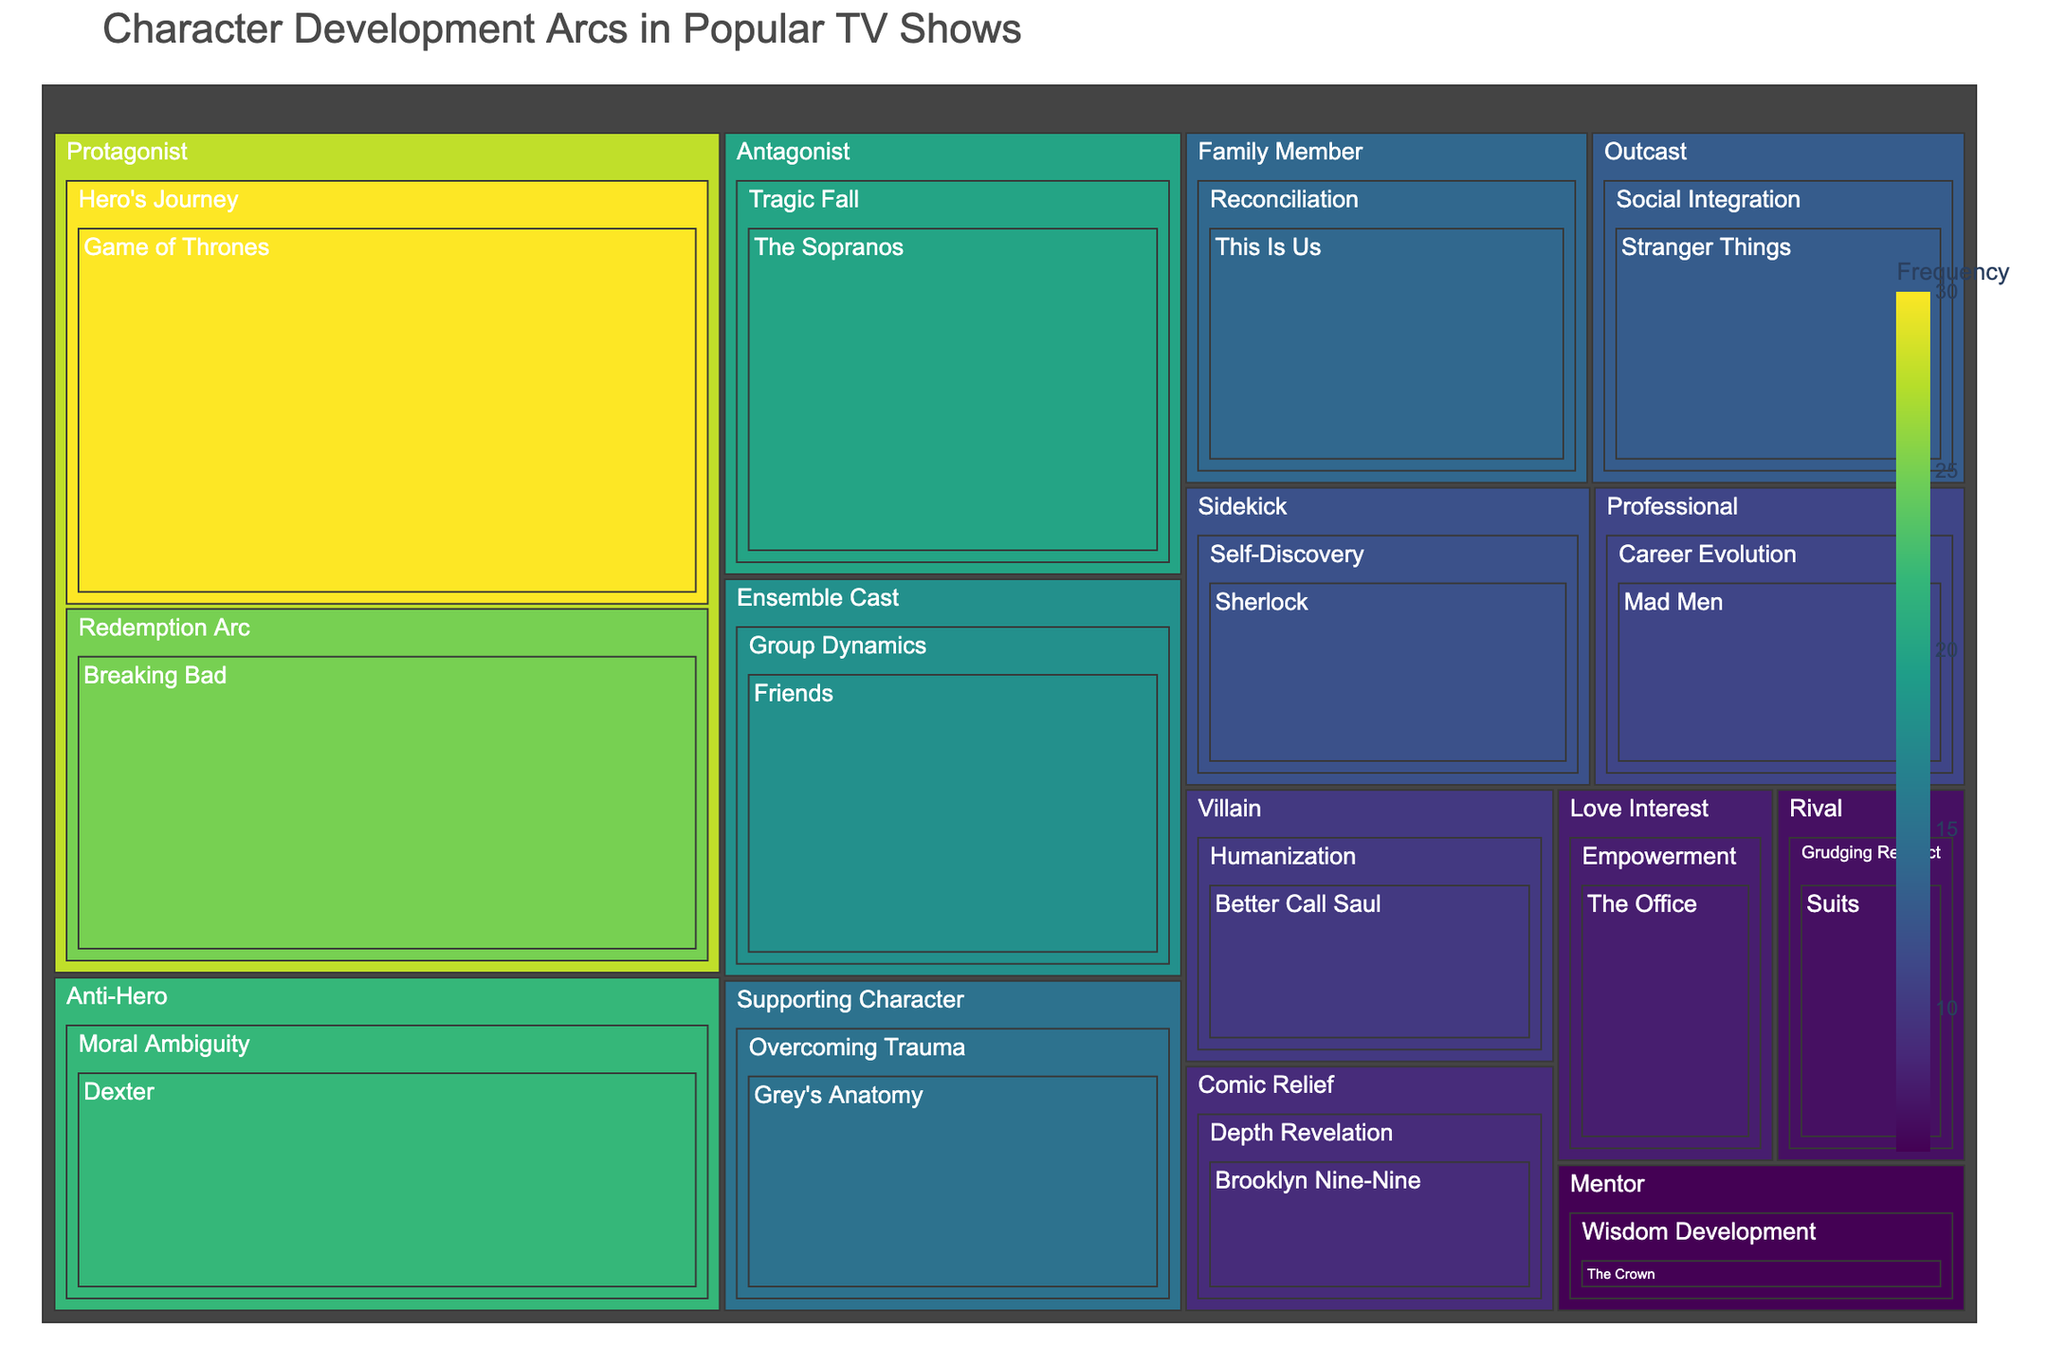What is the title of the treemap? The title is prominently displayed at the top of the treemap.
Answer: Character Development Arcs in Popular TV Shows Which character type has the highest frequency in the treemap? By examining the size and color intensity of the boxes in the treemap, the "Protagonist" appears to have the highest frequency.
Answer: Protagonist How many shows feature characters with a "Redemption Arc" growth pattern? The size and labels of the boxes under "Protagonist" can be inspected for the "Redemption Arc" growth pattern.
Answer: One Which show has the highest frequency of character development arcs overall? Summing up the individual frequencies for each show and comparing them will reveal the show with the highest total frequency.
Answer: Game of Thrones Compare the frequency of the "Villain" character type with a "Humanization" growth pattern to the "Anti-Hero" character type with a "Moral Ambiguity" growth pattern. Which is more frequent and by how much? Check the frequencies for "Villain" with "Humanization" and "Anti-Hero" with "Moral Ambiguity" and subtract to find the difference.
Answer: Moral Ambiguity; by 12 Which show features an "Empowerment" growth pattern, and what is its frequency? Identify the label "Empowerment" under any character type in the treemap and read its frequency.
Answer: The Office; 8 List the growth patterns that belong to the "Supporting Character" type. Examine the box labeled "Supporting Character" and enumerate the growth patterns listed under it.
Answer: Overcoming Trauma What is the overall frequency of character development arcs that address "Overcoming Trauma" and "Career Evolution"? Sum the frequencies of "Overcoming Trauma" and "Career Evolution" shown in their respective labeled boxes.
Answer: 26 Which character type associated with the "Protagonist" has the highest frequency of psychological growth patterns, and what is that frequency? Check the boxes under "Protagonist" and identify which growth pattern has the highest frequency.
Answer: Hero's Journey; 30 What is the least frequent growth pattern among all character types? By comparing the frequencies of all growth patterns visually, the smallest box with the least intense color represents the least frequent pattern.
Answer: Wisdom Development 